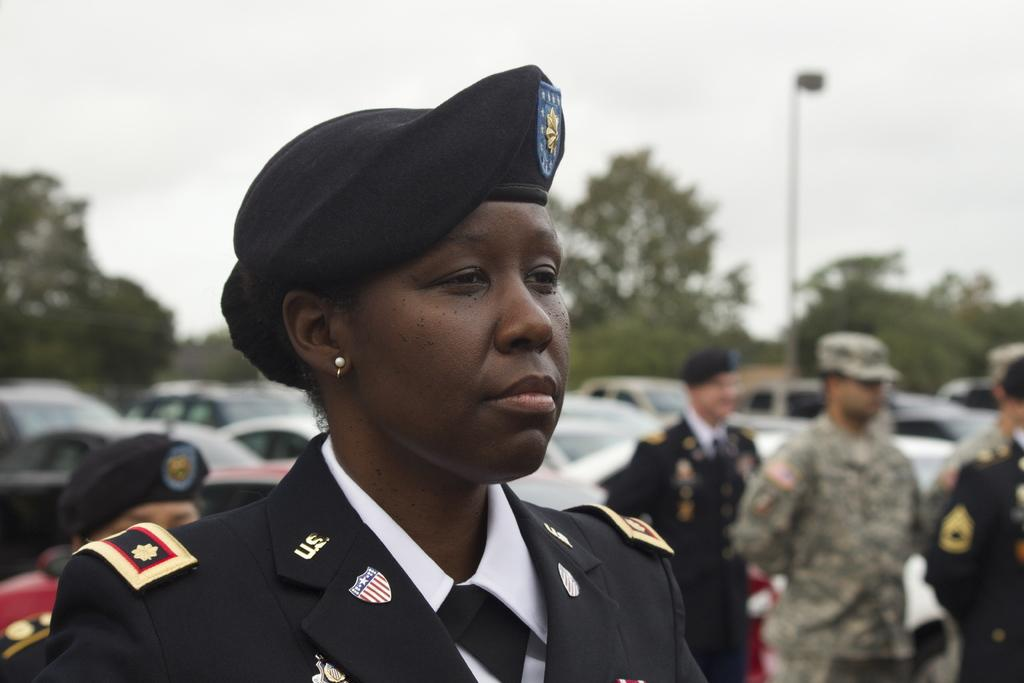What is the person in the image wearing? The person is wearing a black and white dress and a cap. Can you describe the people in the background of the image? There are people visible in the background of the image. What else can be seen in the background of the image? There are vehicles and trees in the background of the image. What is the color of the sky in the image? The sky is white in color. What type of copper material is being used by the bee in the image? There is no bee or copper material present in the image. Is there a locket hanging from the person's neck in the image? There is no mention of a locket in the provided facts, so it cannot be determined if one is present in the image. 